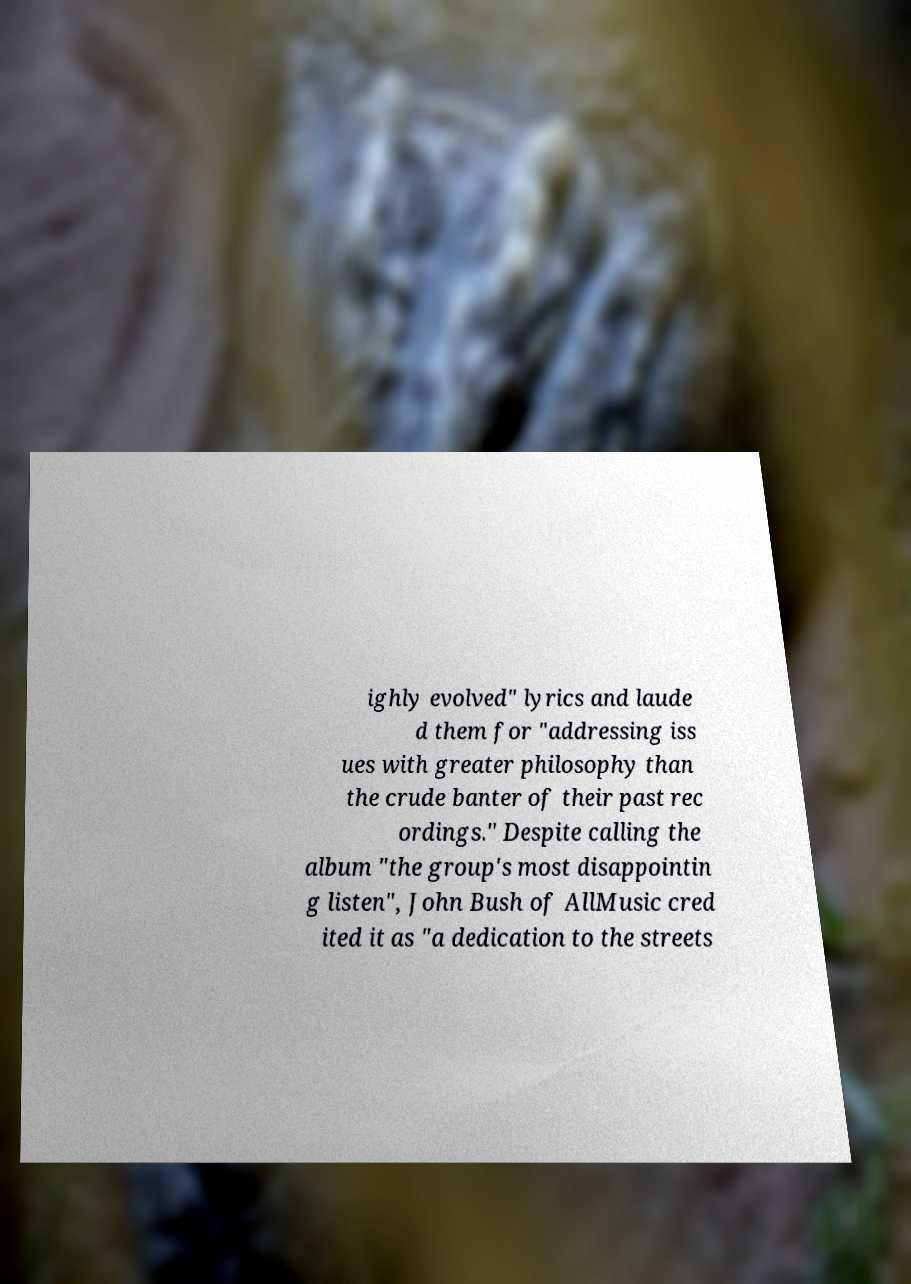For documentation purposes, I need the text within this image transcribed. Could you provide that? ighly evolved" lyrics and laude d them for "addressing iss ues with greater philosophy than the crude banter of their past rec ordings." Despite calling the album "the group's most disappointin g listen", John Bush of AllMusic cred ited it as "a dedication to the streets 